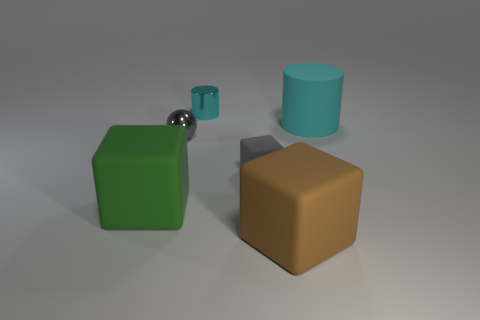Is the number of tiny blue metal objects less than the number of cylinders?
Offer a terse response. Yes. Is the shape of the large green thing the same as the large brown thing in front of the small block?
Keep it short and to the point. Yes. The big rubber object that is both to the right of the cyan metallic cylinder and in front of the shiny ball has what shape?
Give a very brief answer. Cube. Are there the same number of tiny gray metal balls to the right of the large cyan rubber thing and small shiny cylinders that are behind the big green matte thing?
Offer a very short reply. No. There is a big thing that is behind the small metal sphere; is its shape the same as the big brown thing?
Give a very brief answer. No. How many purple things are cylinders or metal spheres?
Offer a very short reply. 0. There is another object that is the same shape as the big cyan rubber thing; what is its material?
Ensure brevity in your answer.  Metal. There is a gray object to the right of the small gray metallic thing; what is its shape?
Give a very brief answer. Cube. Are there any blocks that have the same material as the green thing?
Keep it short and to the point. Yes. Is the size of the cyan rubber cylinder the same as the ball?
Your answer should be very brief. No. 